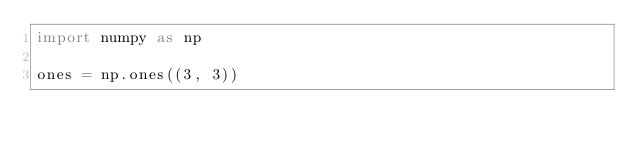Convert code to text. <code><loc_0><loc_0><loc_500><loc_500><_Python_>import numpy as np

ones = np.ones((3, 3))
</code> 